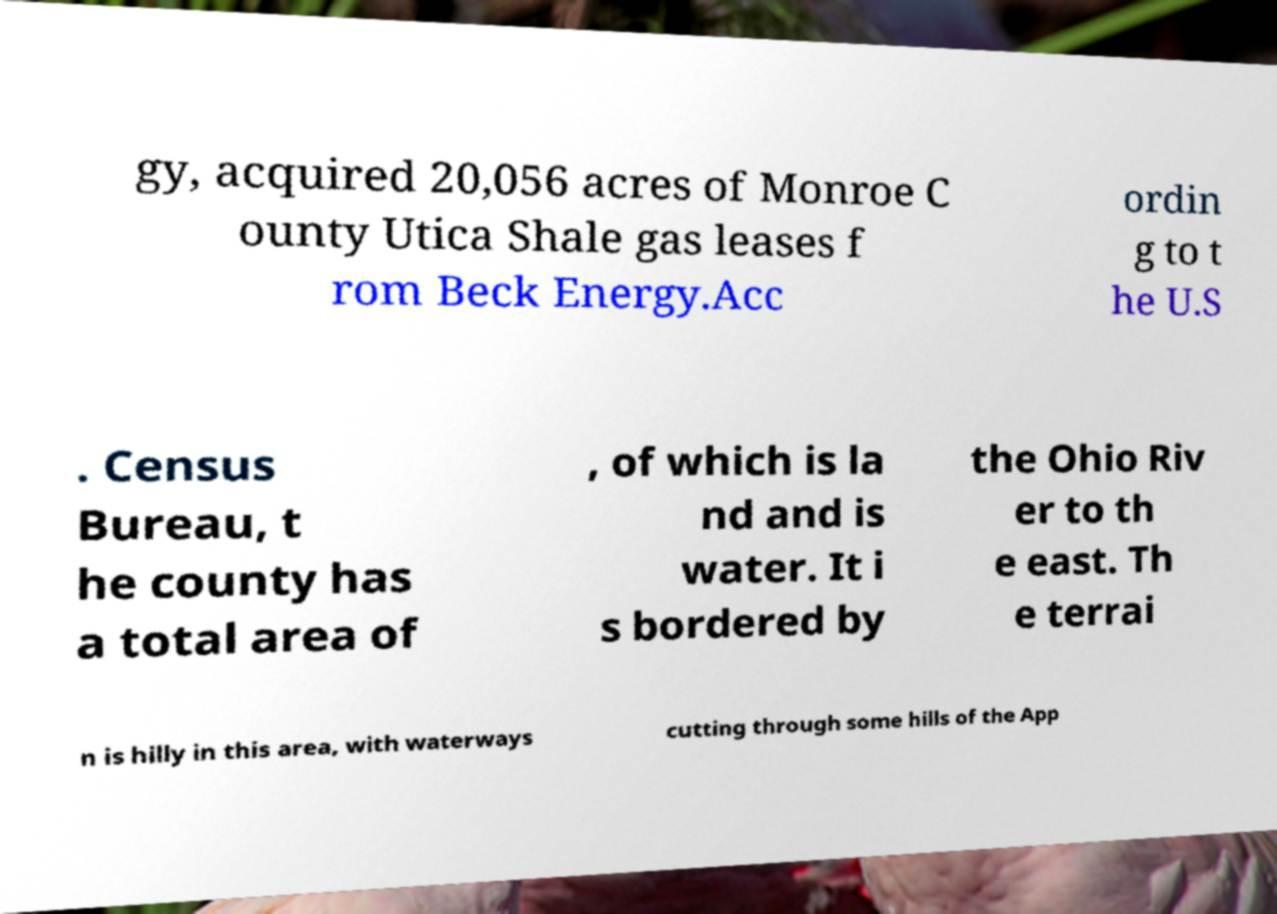What messages or text are displayed in this image? I need them in a readable, typed format. gy, acquired 20,056 acres of Monroe C ounty Utica Shale gas leases f rom Beck Energy.Acc ordin g to t he U.S . Census Bureau, t he county has a total area of , of which is la nd and is water. It i s bordered by the Ohio Riv er to th e east. Th e terrai n is hilly in this area, with waterways cutting through some hills of the App 